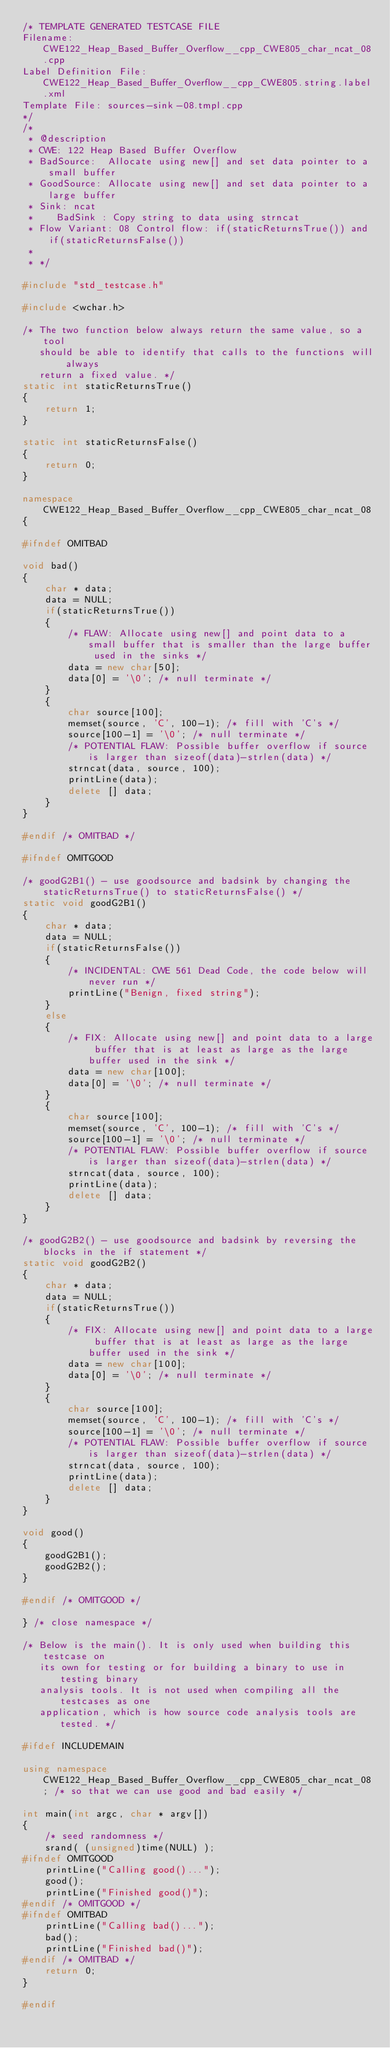<code> <loc_0><loc_0><loc_500><loc_500><_C++_>/* TEMPLATE GENERATED TESTCASE FILE
Filename: CWE122_Heap_Based_Buffer_Overflow__cpp_CWE805_char_ncat_08.cpp
Label Definition File: CWE122_Heap_Based_Buffer_Overflow__cpp_CWE805.string.label.xml
Template File: sources-sink-08.tmpl.cpp
*/
/*
 * @description
 * CWE: 122 Heap Based Buffer Overflow
 * BadSource:  Allocate using new[] and set data pointer to a small buffer
 * GoodSource: Allocate using new[] and set data pointer to a large buffer
 * Sink: ncat
 *    BadSink : Copy string to data using strncat
 * Flow Variant: 08 Control flow: if(staticReturnsTrue()) and if(staticReturnsFalse())
 *
 * */

#include "std_testcase.h"

#include <wchar.h>

/* The two function below always return the same value, so a tool
   should be able to identify that calls to the functions will always
   return a fixed value. */
static int staticReturnsTrue()
{
    return 1;
}

static int staticReturnsFalse()
{
    return 0;
}

namespace CWE122_Heap_Based_Buffer_Overflow__cpp_CWE805_char_ncat_08
{

#ifndef OMITBAD

void bad()
{
    char * data;
    data = NULL;
    if(staticReturnsTrue())
    {
        /* FLAW: Allocate using new[] and point data to a small buffer that is smaller than the large buffer used in the sinks */
        data = new char[50];
        data[0] = '\0'; /* null terminate */
    }
    {
        char source[100];
        memset(source, 'C', 100-1); /* fill with 'C's */
        source[100-1] = '\0'; /* null terminate */
        /* POTENTIAL FLAW: Possible buffer overflow if source is larger than sizeof(data)-strlen(data) */
        strncat(data, source, 100);
        printLine(data);
        delete [] data;
    }
}

#endif /* OMITBAD */

#ifndef OMITGOOD

/* goodG2B1() - use goodsource and badsink by changing the staticReturnsTrue() to staticReturnsFalse() */
static void goodG2B1()
{
    char * data;
    data = NULL;
    if(staticReturnsFalse())
    {
        /* INCIDENTAL: CWE 561 Dead Code, the code below will never run */
        printLine("Benign, fixed string");
    }
    else
    {
        /* FIX: Allocate using new[] and point data to a large buffer that is at least as large as the large buffer used in the sink */
        data = new char[100];
        data[0] = '\0'; /* null terminate */
    }
    {
        char source[100];
        memset(source, 'C', 100-1); /* fill with 'C's */
        source[100-1] = '\0'; /* null terminate */
        /* POTENTIAL FLAW: Possible buffer overflow if source is larger than sizeof(data)-strlen(data) */
        strncat(data, source, 100);
        printLine(data);
        delete [] data;
    }
}

/* goodG2B2() - use goodsource and badsink by reversing the blocks in the if statement */
static void goodG2B2()
{
    char * data;
    data = NULL;
    if(staticReturnsTrue())
    {
        /* FIX: Allocate using new[] and point data to a large buffer that is at least as large as the large buffer used in the sink */
        data = new char[100];
        data[0] = '\0'; /* null terminate */
    }
    {
        char source[100];
        memset(source, 'C', 100-1); /* fill with 'C's */
        source[100-1] = '\0'; /* null terminate */
        /* POTENTIAL FLAW: Possible buffer overflow if source is larger than sizeof(data)-strlen(data) */
        strncat(data, source, 100);
        printLine(data);
        delete [] data;
    }
}

void good()
{
    goodG2B1();
    goodG2B2();
}

#endif /* OMITGOOD */

} /* close namespace */

/* Below is the main(). It is only used when building this testcase on
   its own for testing or for building a binary to use in testing binary
   analysis tools. It is not used when compiling all the testcases as one
   application, which is how source code analysis tools are tested. */

#ifdef INCLUDEMAIN

using namespace CWE122_Heap_Based_Buffer_Overflow__cpp_CWE805_char_ncat_08; /* so that we can use good and bad easily */

int main(int argc, char * argv[])
{
    /* seed randomness */
    srand( (unsigned)time(NULL) );
#ifndef OMITGOOD
    printLine("Calling good()...");
    good();
    printLine("Finished good()");
#endif /* OMITGOOD */
#ifndef OMITBAD
    printLine("Calling bad()...");
    bad();
    printLine("Finished bad()");
#endif /* OMITBAD */
    return 0;
}

#endif
</code> 